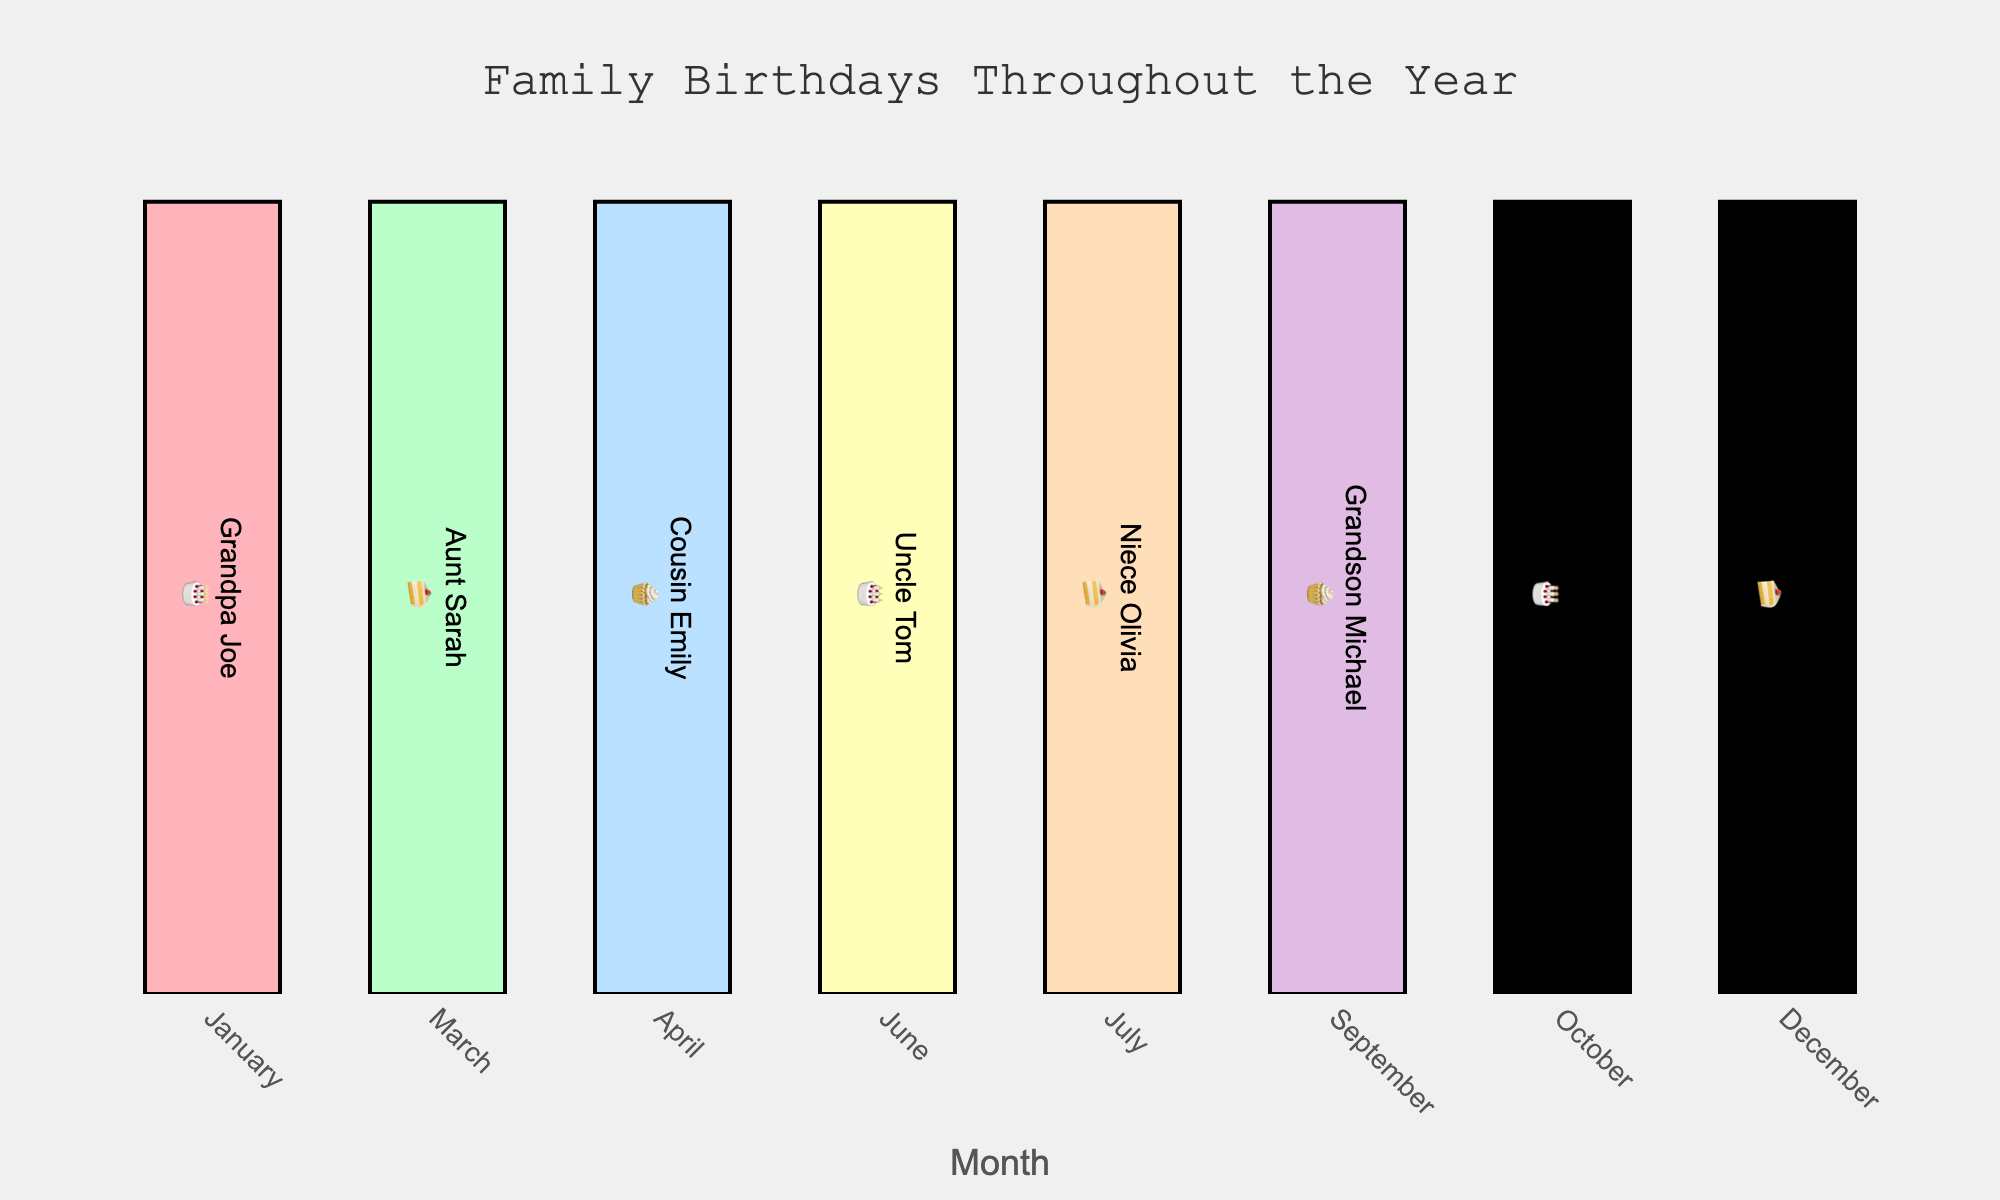What is the title of the figure? The title of the figure is typically found at the top of the plot and serves to inform viewers about the main subject of the chart. In this case, the title is "Family Birthdays Throughout the Year" as indicated by the update_layout section of the code.
Answer: Family Birthdays Throughout the Year Which month has the most birthdays? To find the month with the most birthdays, observe the month column and count how many family members have their birthdays in each month. Each month listed only has one birthday, so no single month has more birthdays than another.
Answer: Each month has 1 birthday How many family members have their birthdays in July? By examining the "Birthday Month" column, we see that "July" appears once, which means only one person has a birthday in July.
Answer: 1 Who has their birthday in October? Look at the "Birthday Month" column to find October, then check the corresponding "Family Member" entry, which is "Daughter-in-law Lisa."
Answer: Daughter-in-law Lisa Compare the number of birthdays between the first and last quarters of the year (January to March vs. October to December). First, sum up the number of birthdays from January, February, and March, which includes "Grandpa Joe" and "Aunt Sarah" for a total of 2. Then, sum up the birthdays from October, November, and December, which includes "Daughter-in-law Lisa" and "Son David" for a total of 2. Both quarters have the same number of birthdays.
Answer: 2 in each quarter Which family members' birthdays are in the second quarter (April to June)? Check the entries in the "Birthday Month" column for April, May, and June to find "Cousin Emily" and "Uncle Tom" having birthdays in the second quarter.
Answer: Cousin Emily and Uncle Tom How many more birthdays are there in the summer months (June, July, August) compared to the winter months (December, January, February)? Calculate the number of birthdays in summer (June, July, August) as 2 (Uncle Tom and Niece Olivia) and the number of birthdays in winter (December, January, February) as 2 (Grandpa Joe and Son David). The difference is zero.
Answer: 0 What type of birthday dessert icon is most common? The "Birthday Emoji" column shows the dessert icons. Count each type to determine which is most frequent. There's 🎂 (Grandpa Joe, Uncle Tom, Daughter-in-law Lisa), 🍰 (Aunt Sarah, Niece Olivia, Son David), and 🧁 (Cousin Emily, Grandson Michael). 🎂 and 🍰 are tied for most common, each with three occurrences.
Answer: 🎂 and 🍰 Which family member has a birthday first in the year? By noting the months from January to December, "Grandpa Joe" in January is seen first chronologically.
Answer: Grandpa Joe If each birthday is celebrated with the depicted dessert, how many cakes 🎂 would be needed for the whole year? Count the instances of the 🎂 emoji in the "Birthday Emoji" column. There are three instances (Grandpa Joe, Uncle Tom, Daughter-in-law Lisa).
Answer: 3 